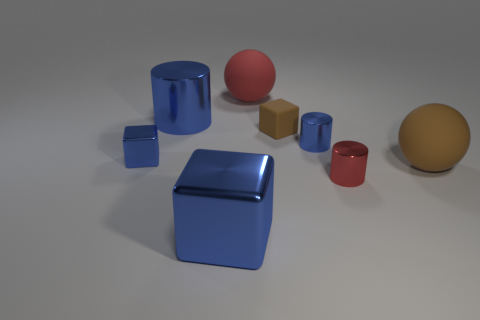There is a cube that is the same size as the red rubber thing; what is its material?
Give a very brief answer. Metal. Is there a small yellow cube made of the same material as the large brown ball?
Give a very brief answer. No. Is the number of tiny red metal cylinders right of the small brown rubber object less than the number of tiny purple rubber cylinders?
Your response must be concise. No. What is the blue cube that is in front of the large rubber sphere that is in front of the red rubber thing made of?
Offer a terse response. Metal. What shape is the large thing that is both in front of the brown cube and behind the large blue cube?
Provide a succinct answer. Sphere. What number of other objects are there of the same color as the rubber cube?
Your response must be concise. 1. What number of things are either small things to the left of the red cylinder or tiny brown rubber blocks?
Provide a succinct answer. 3. Do the big shiny block and the tiny metallic object that is on the left side of the red rubber sphere have the same color?
Make the answer very short. Yes. There is a blue cube in front of the big ball that is in front of the big red rubber thing; what size is it?
Your answer should be very brief. Large. What number of objects are either rubber balls or large cylinders behind the tiny red cylinder?
Make the answer very short. 3. 